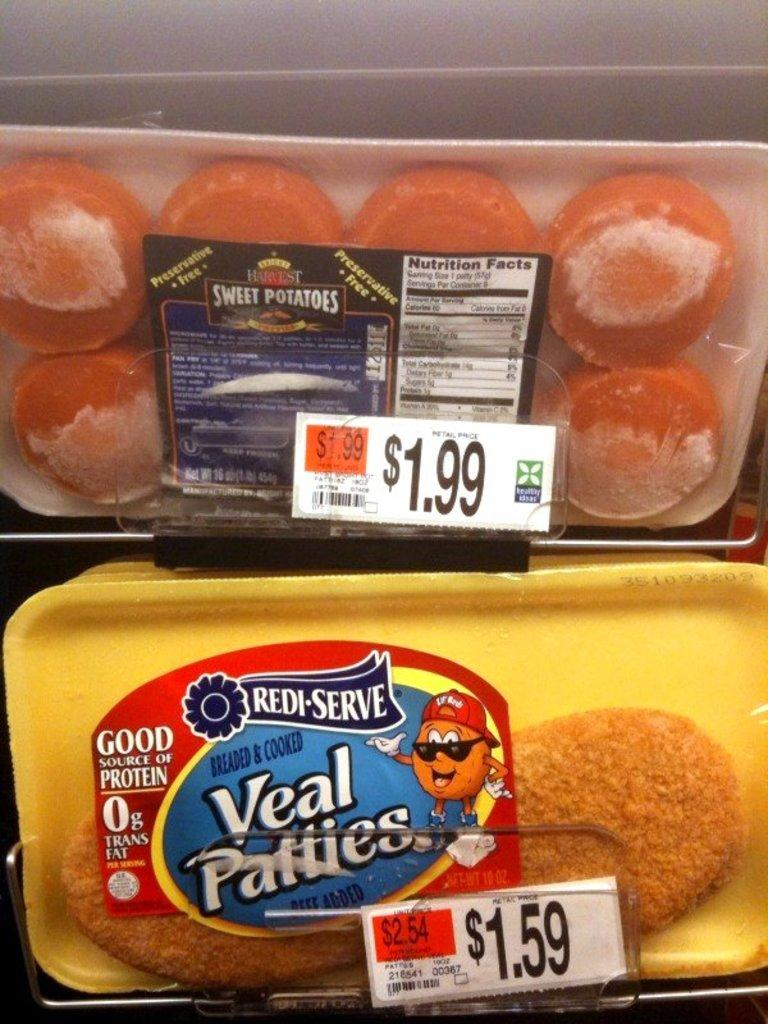How many boxes are visible in the image? There are two boxes in the image. What is on the boxes can be seen in the image? Stickers are attached to the boxes. What other objects are present in the image? There are white color boards in the image. What month is depicted on the stickers attached to the boxes? There is no indication of a month on the stickers attached to the boxes in the image. 